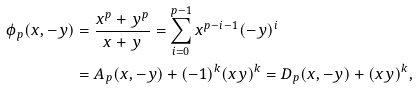Convert formula to latex. <formula><loc_0><loc_0><loc_500><loc_500>\phi _ { p } ( x , - y ) & = \frac { x ^ { p } + y ^ { p } } { x + y } = \sum _ { i = 0 } ^ { p - 1 } x ^ { p - i - 1 } ( - y ) ^ { i } \\ & = A _ { p } ( x , - y ) + ( - 1 ) ^ { k } ( x y ) ^ { k } = D _ { p } ( x , - y ) + ( x y ) ^ { k } , \\</formula> 